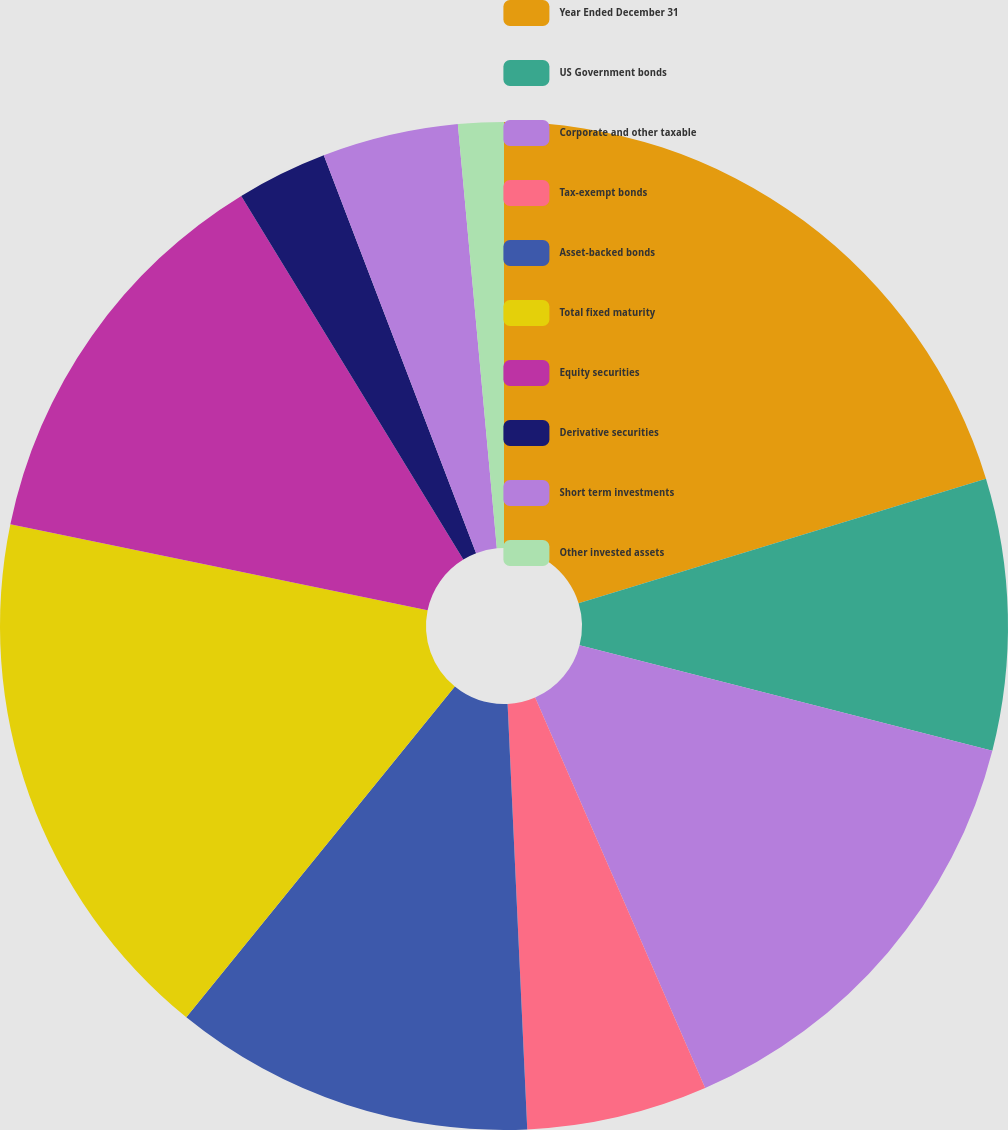Convert chart. <chart><loc_0><loc_0><loc_500><loc_500><pie_chart><fcel>Year Ended December 31<fcel>US Government bonds<fcel>Corporate and other taxable<fcel>Tax-exempt bonds<fcel>Asset-backed bonds<fcel>Total fixed maturity<fcel>Equity securities<fcel>Derivative securities<fcel>Short term investments<fcel>Other invested assets<nl><fcel>20.28%<fcel>8.7%<fcel>14.49%<fcel>5.8%<fcel>11.59%<fcel>17.38%<fcel>13.04%<fcel>2.91%<fcel>4.36%<fcel>1.46%<nl></chart> 